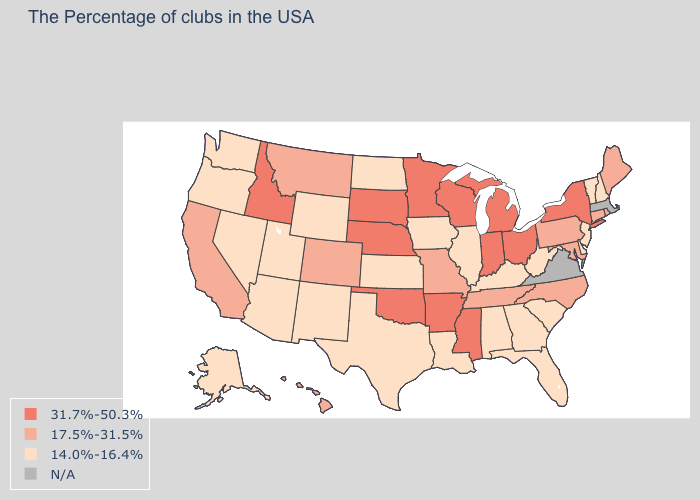What is the highest value in states that border Kansas?
Give a very brief answer. 31.7%-50.3%. Which states have the highest value in the USA?
Give a very brief answer. New York, Ohio, Michigan, Indiana, Wisconsin, Mississippi, Arkansas, Minnesota, Nebraska, Oklahoma, South Dakota, Idaho. What is the value of New York?
Short answer required. 31.7%-50.3%. Which states have the lowest value in the West?
Give a very brief answer. Wyoming, New Mexico, Utah, Arizona, Nevada, Washington, Oregon, Alaska. Name the states that have a value in the range 14.0%-16.4%?
Write a very short answer. New Hampshire, Vermont, New Jersey, Delaware, South Carolina, West Virginia, Florida, Georgia, Kentucky, Alabama, Illinois, Louisiana, Iowa, Kansas, Texas, North Dakota, Wyoming, New Mexico, Utah, Arizona, Nevada, Washington, Oregon, Alaska. Which states have the highest value in the USA?
Short answer required. New York, Ohio, Michigan, Indiana, Wisconsin, Mississippi, Arkansas, Minnesota, Nebraska, Oklahoma, South Dakota, Idaho. Does New York have the highest value in the USA?
Concise answer only. Yes. Which states have the highest value in the USA?
Concise answer only. New York, Ohio, Michigan, Indiana, Wisconsin, Mississippi, Arkansas, Minnesota, Nebraska, Oklahoma, South Dakota, Idaho. Which states have the lowest value in the USA?
Answer briefly. New Hampshire, Vermont, New Jersey, Delaware, South Carolina, West Virginia, Florida, Georgia, Kentucky, Alabama, Illinois, Louisiana, Iowa, Kansas, Texas, North Dakota, Wyoming, New Mexico, Utah, Arizona, Nevada, Washington, Oregon, Alaska. Name the states that have a value in the range N/A?
Quick response, please. Massachusetts, Virginia. What is the value of Idaho?
Concise answer only. 31.7%-50.3%. Name the states that have a value in the range N/A?
Keep it brief. Massachusetts, Virginia. Name the states that have a value in the range 31.7%-50.3%?
Give a very brief answer. New York, Ohio, Michigan, Indiana, Wisconsin, Mississippi, Arkansas, Minnesota, Nebraska, Oklahoma, South Dakota, Idaho. Which states have the highest value in the USA?
Concise answer only. New York, Ohio, Michigan, Indiana, Wisconsin, Mississippi, Arkansas, Minnesota, Nebraska, Oklahoma, South Dakota, Idaho. 